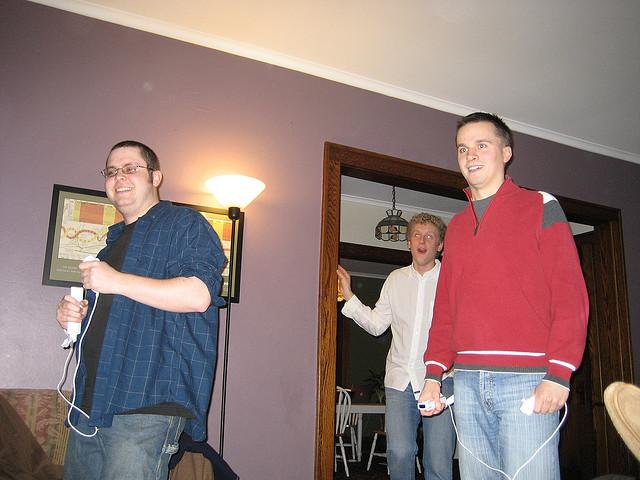What are they looking at?

Choices:
A) small child
B) soap opera
C) video screen
D) trained puppy video screen 